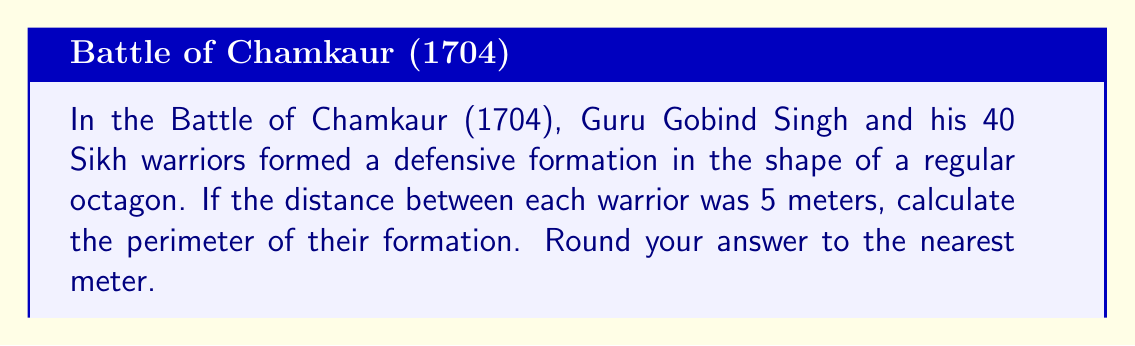Can you answer this question? To solve this problem, we need to follow these steps:

1. Understand the shape: A regular octagon has 8 equal sides.

2. Calculate the length of one side:
   - With 40 warriors, there are 5 warriors on each side of the octagon.
   - The distance between each warrior is 5 meters.
   - So, the length of one side is: $5 \text{ meters} \times 4 = 20 \text{ meters}$

3. Calculate the perimeter:
   - The perimeter is the sum of all sides.
   - For a regular octagon, this is simply 8 times the length of one side.
   - Perimeter $= 8 \times 20 \text{ meters} = 160 \text{ meters}$

[asy]
unitsize(1cm);
pair A = (0,0);
pair B = (2,0);
pair C = (3.414,1.414);
pair D = (3.414,2.828);
pair E = (2,4.242);
pair F = (0,4.242);
pair G = (-1.414,2.828);
pair H = (-1.414,1.414);

draw(A--B--C--D--E--F--G--H--cycle);
label("5m", (A+B)/2, S);
label("20m", (A+H)/2, NW);
[/asy]

The diagram above illustrates the octagonal formation, showing the 5-meter spacing between warriors and the 20-meter side length.
Answer: The perimeter of the Sikh battle formation is 160 meters. 